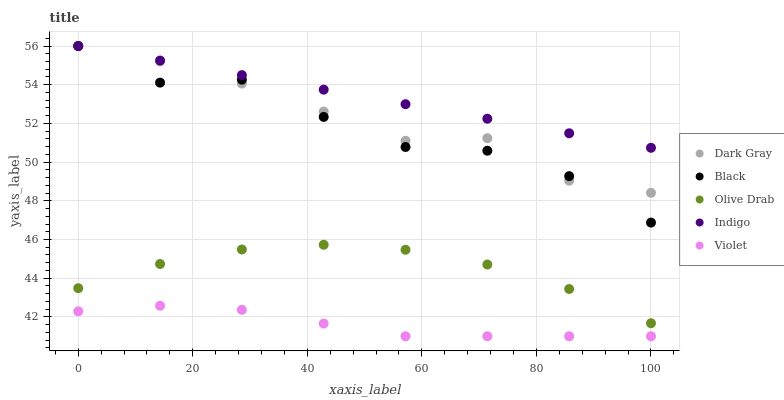Does Violet have the minimum area under the curve?
Answer yes or no. Yes. Does Indigo have the maximum area under the curve?
Answer yes or no. Yes. Does Black have the minimum area under the curve?
Answer yes or no. No. Does Black have the maximum area under the curve?
Answer yes or no. No. Is Indigo the smoothest?
Answer yes or no. Yes. Is Black the roughest?
Answer yes or no. Yes. Is Black the smoothest?
Answer yes or no. No. Is Indigo the roughest?
Answer yes or no. No. Does Violet have the lowest value?
Answer yes or no. Yes. Does Black have the lowest value?
Answer yes or no. No. Does Black have the highest value?
Answer yes or no. Yes. Does Olive Drab have the highest value?
Answer yes or no. No. Is Violet less than Indigo?
Answer yes or no. Yes. Is Black greater than Olive Drab?
Answer yes or no. Yes. Does Dark Gray intersect Black?
Answer yes or no. Yes. Is Dark Gray less than Black?
Answer yes or no. No. Is Dark Gray greater than Black?
Answer yes or no. No. Does Violet intersect Indigo?
Answer yes or no. No. 